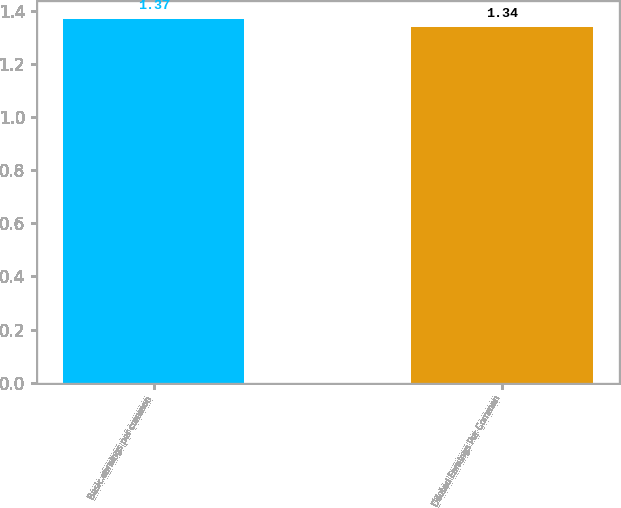<chart> <loc_0><loc_0><loc_500><loc_500><bar_chart><fcel>Basic earnings per common<fcel>Diluted Earnings Per Common<nl><fcel>1.37<fcel>1.34<nl></chart> 